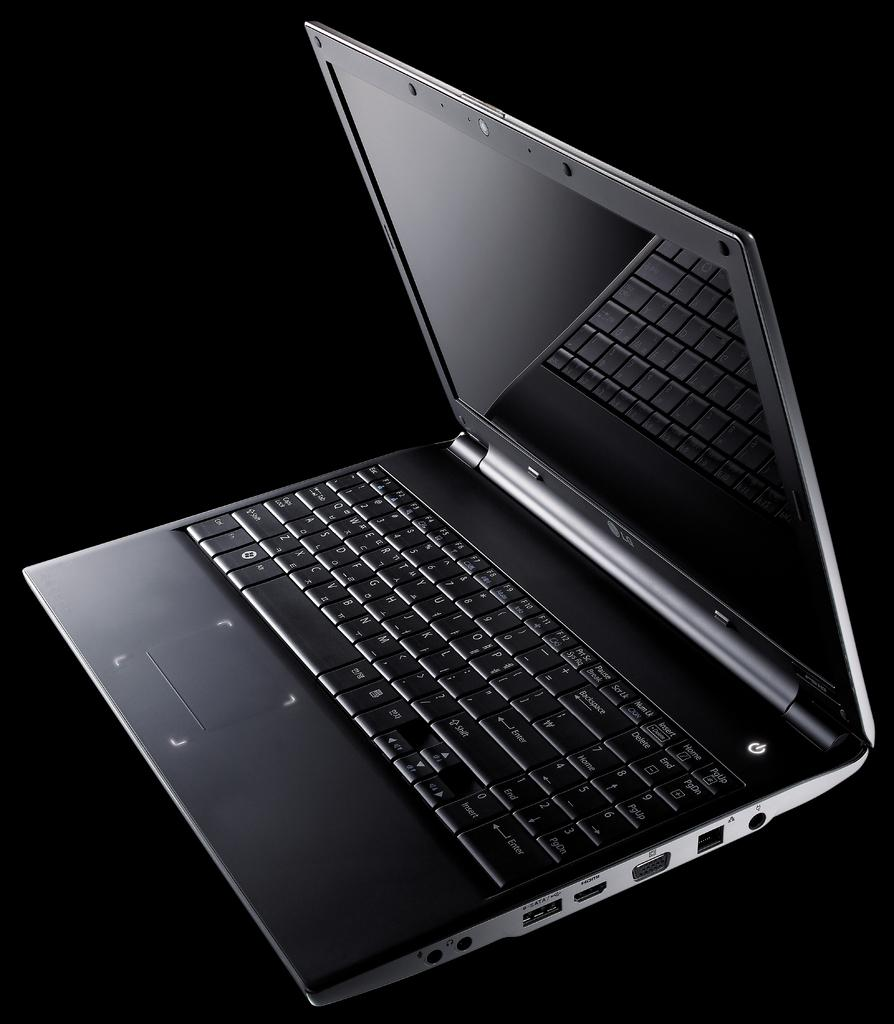Provide a one-sentence caption for the provided image. An LG portable lap top computer that is black and sleek. 